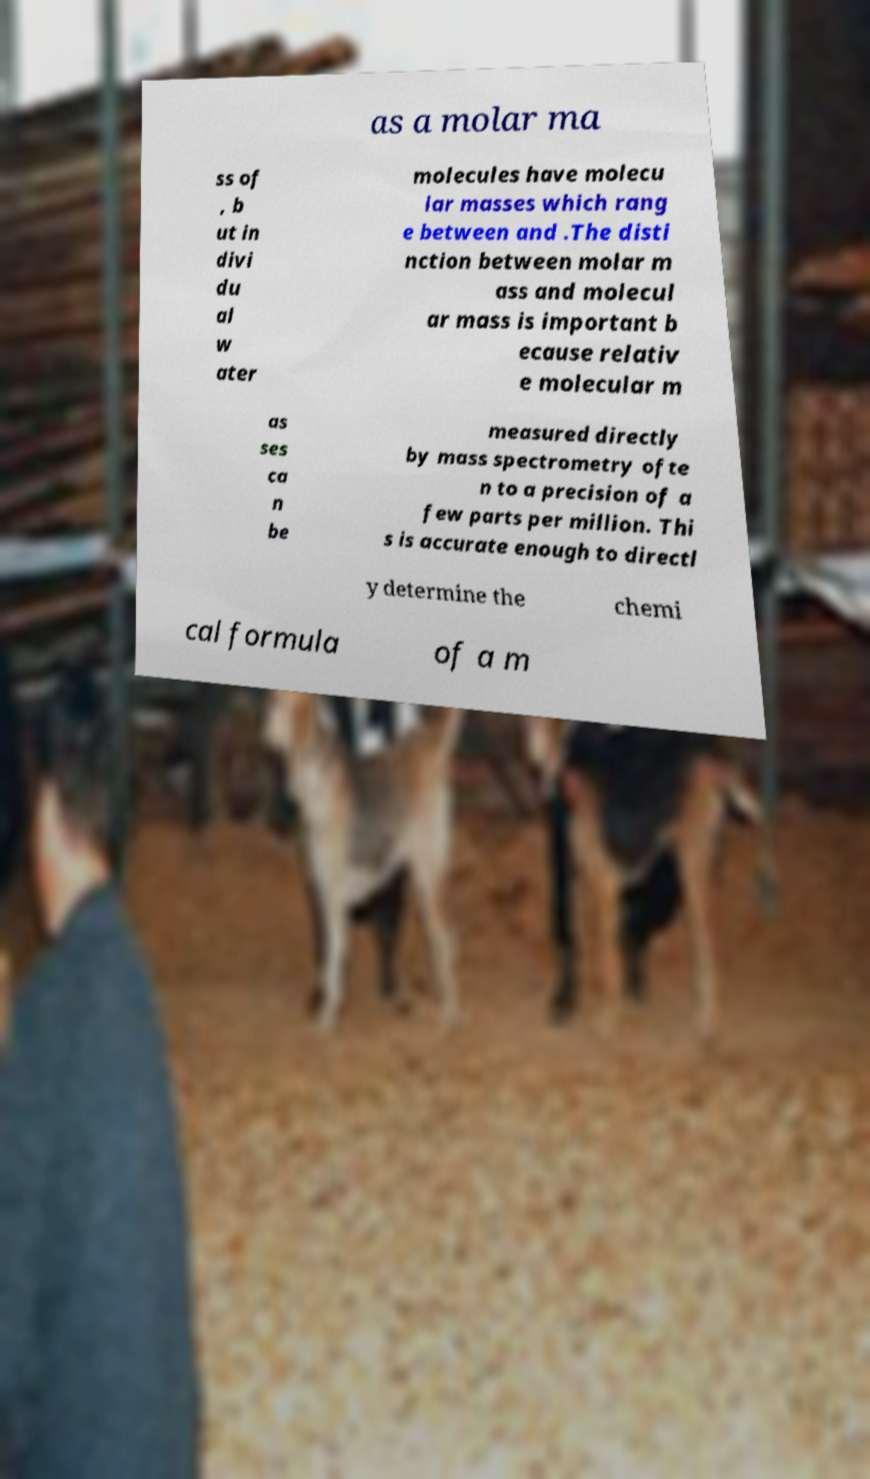Can you accurately transcribe the text from the provided image for me? as a molar ma ss of , b ut in divi du al w ater molecules have molecu lar masses which rang e between and .The disti nction between molar m ass and molecul ar mass is important b ecause relativ e molecular m as ses ca n be measured directly by mass spectrometry ofte n to a precision of a few parts per million. Thi s is accurate enough to directl y determine the chemi cal formula of a m 